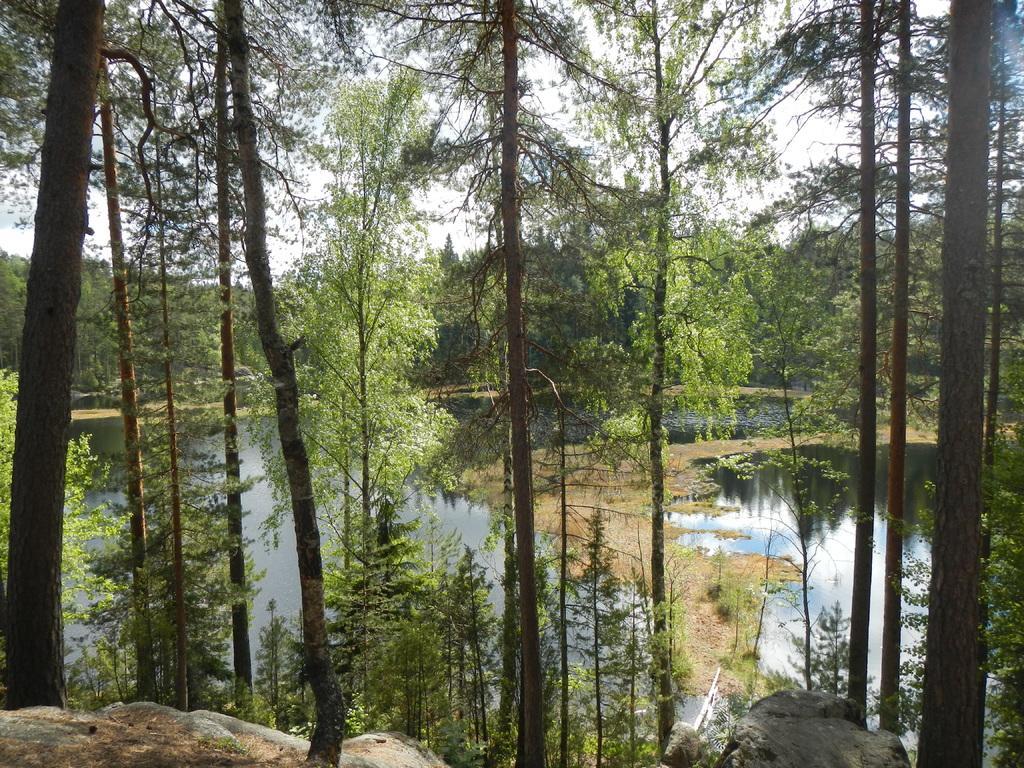Could you give a brief overview of what you see in this image? In the foreground of the image we can see rocks, trees and water body. In the middle of the image we can see trees and water body. On the top of the image we can see trees and some part of the sky. 